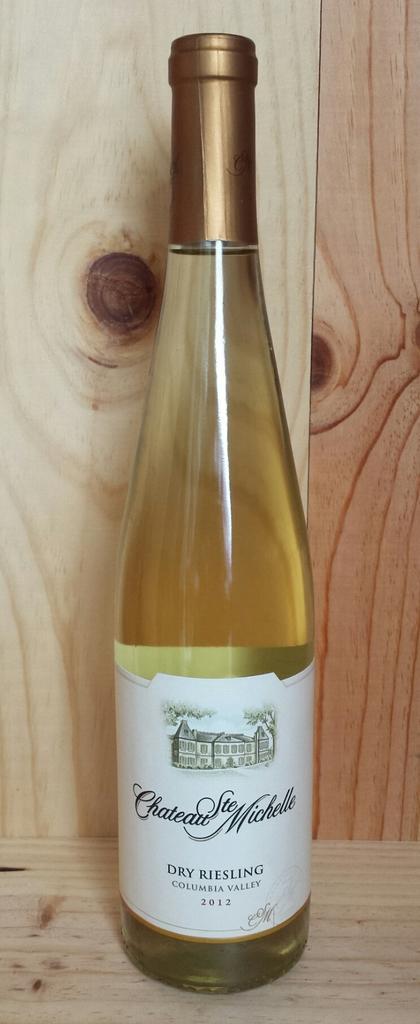Please provide a concise description of this image. In the image there is bottle placed on a table maybe this is a wine bottle. There is a sticker attached to the bottle. 